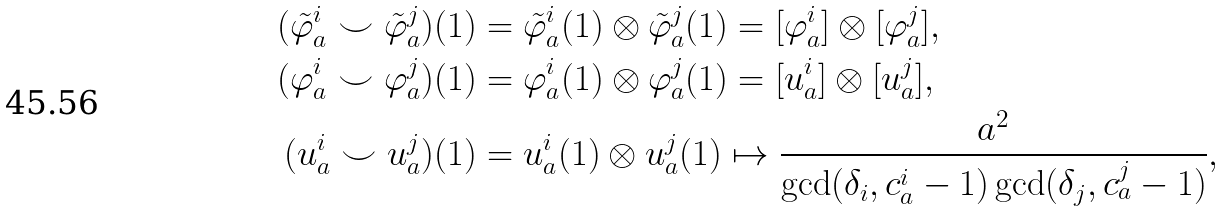Convert formula to latex. <formula><loc_0><loc_0><loc_500><loc_500>( \tilde { \varphi } _ { a } ^ { i } \smile \tilde { \varphi } _ { a } ^ { j } ) ( 1 ) & = \tilde { \varphi } _ { a } ^ { i } ( 1 ) \otimes \tilde { \varphi } _ { a } ^ { j } ( 1 ) = [ \varphi _ { a } ^ { i } ] \otimes [ \varphi _ { a } ^ { j } ] , \\ ( \varphi _ { a } ^ { i } \smile \varphi _ { a } ^ { j } ) ( 1 ) & = \varphi _ { a } ^ { i } ( 1 ) \otimes \varphi _ { a } ^ { j } ( 1 ) = [ u _ { a } ^ { i } ] \otimes [ u _ { a } ^ { j } ] , \\ ( u _ { a } ^ { i } \smile u _ { a } ^ { j } ) ( 1 ) & = u _ { a } ^ { i } ( 1 ) \otimes u _ { a } ^ { j } ( 1 ) \mapsto \frac { a ^ { 2 } } { \gcd ( \delta _ { i } , c _ { a } ^ { i } - 1 ) \gcd ( \delta _ { j } , c _ { a } ^ { j } - 1 ) } ,</formula> 